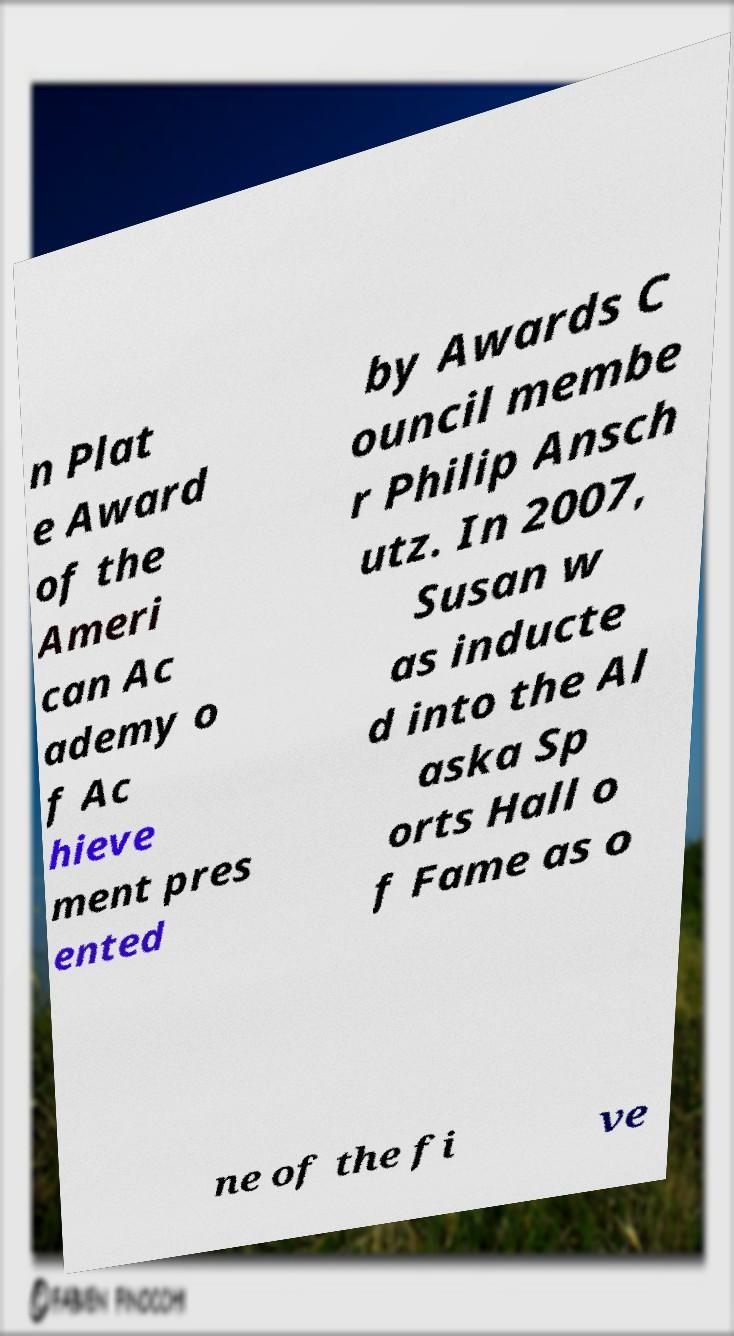Please read and relay the text visible in this image. What does it say? n Plat e Award of the Ameri can Ac ademy o f Ac hieve ment pres ented by Awards C ouncil membe r Philip Ansch utz. In 2007, Susan w as inducte d into the Al aska Sp orts Hall o f Fame as o ne of the fi ve 